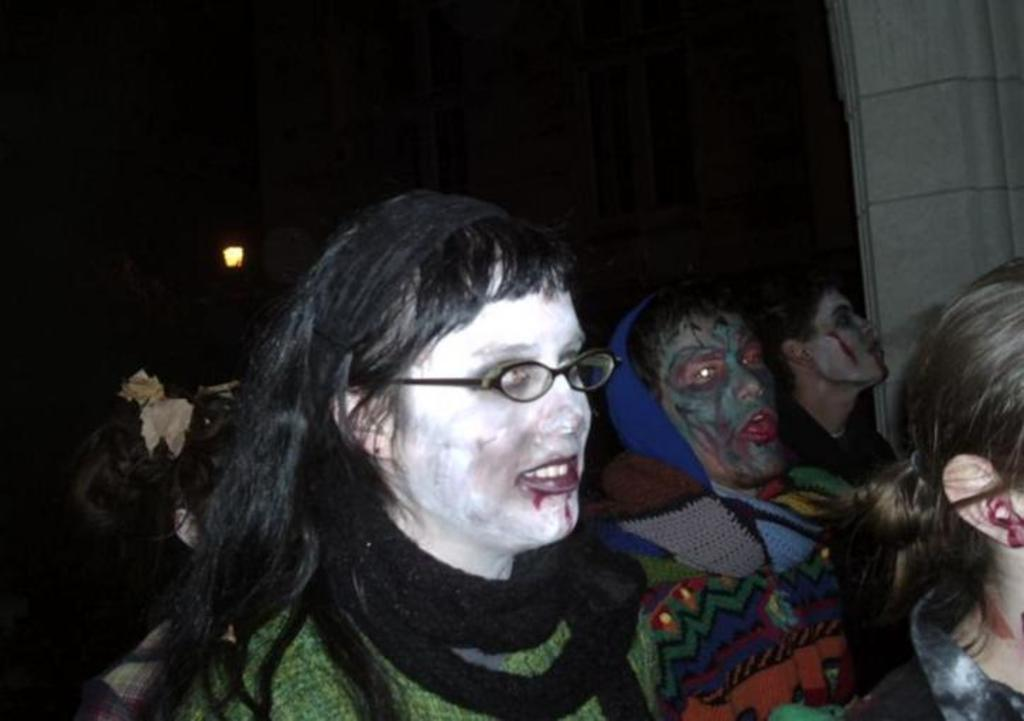Who or what is present in the image? There are people in the image. What can be observed on the faces of the people in the image? The people have face paintings. Where are the people located in the image? The people are located in the center of the image. What type of carriage can be seen in the image? There is no carriage present in the image. How many children are visible in the image? The provided facts do not mention the presence of children in the image. 